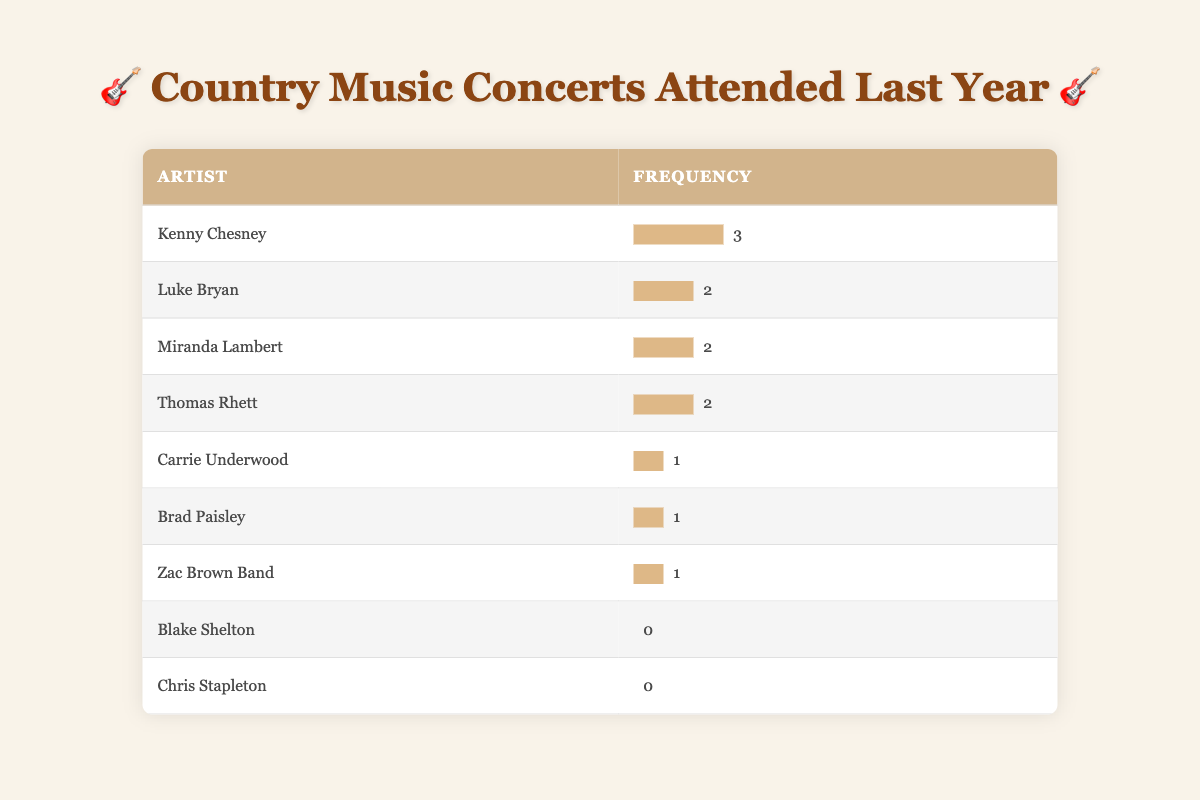What is the frequency of concerts attended for Kenny Chesney? Kenny Chesney is listed in the table with a frequency of 3. This information is directly available in the row corresponding to Kenny Chesney.
Answer: 3 How many different artists have a frequency of 2? The artists with a frequency of 2 are Luke Bryan, Miranda Lambert, and Thomas Rhett. Therefore, we have a total of 3 artists with this frequency.
Answer: 3 Is there an artist who did not attend any concerts in the last year? Yes, both Blake Shelton and Chris Stapleton are listed with a frequency of 0, indicating they did not attend any concerts.
Answer: Yes Which artist attended the most concerts? Kenny Chesney attended the most concerts, with a frequency of 3. This can be determined by comparing the frequencies listed for all artists in the table.
Answer: Kenny Chesney What is the total number of concerts attended by all artists combined? To find the total, we add the frequencies of all artists: 3 + 2 + 2 + 2 + 1 + 1 + 1 + 0 + 0 = 12. Therefore, the total number of concerts attended by all artists is 12.
Answer: 12 What is the frequency of concerts attended for Miranda Lambert? Miranda Lambert has a frequency of 2, as indicated by her row in the table.
Answer: 2 How many artists have attended only one concert? The artists with a frequency of 1 are Carrie Underwood, Brad Paisley, and Zac Brown Band, making a total of 3 artists who attended only one concert.
Answer: 3 Which artist is listed as attending the least number of concerts? Blake Shelton and Chris Stapleton both have a frequency of 0, meaning they did not attend any concerts in the last year; therefore, they are the artists listed as attending the least.
Answer: Blake Shelton and Chris Stapleton 